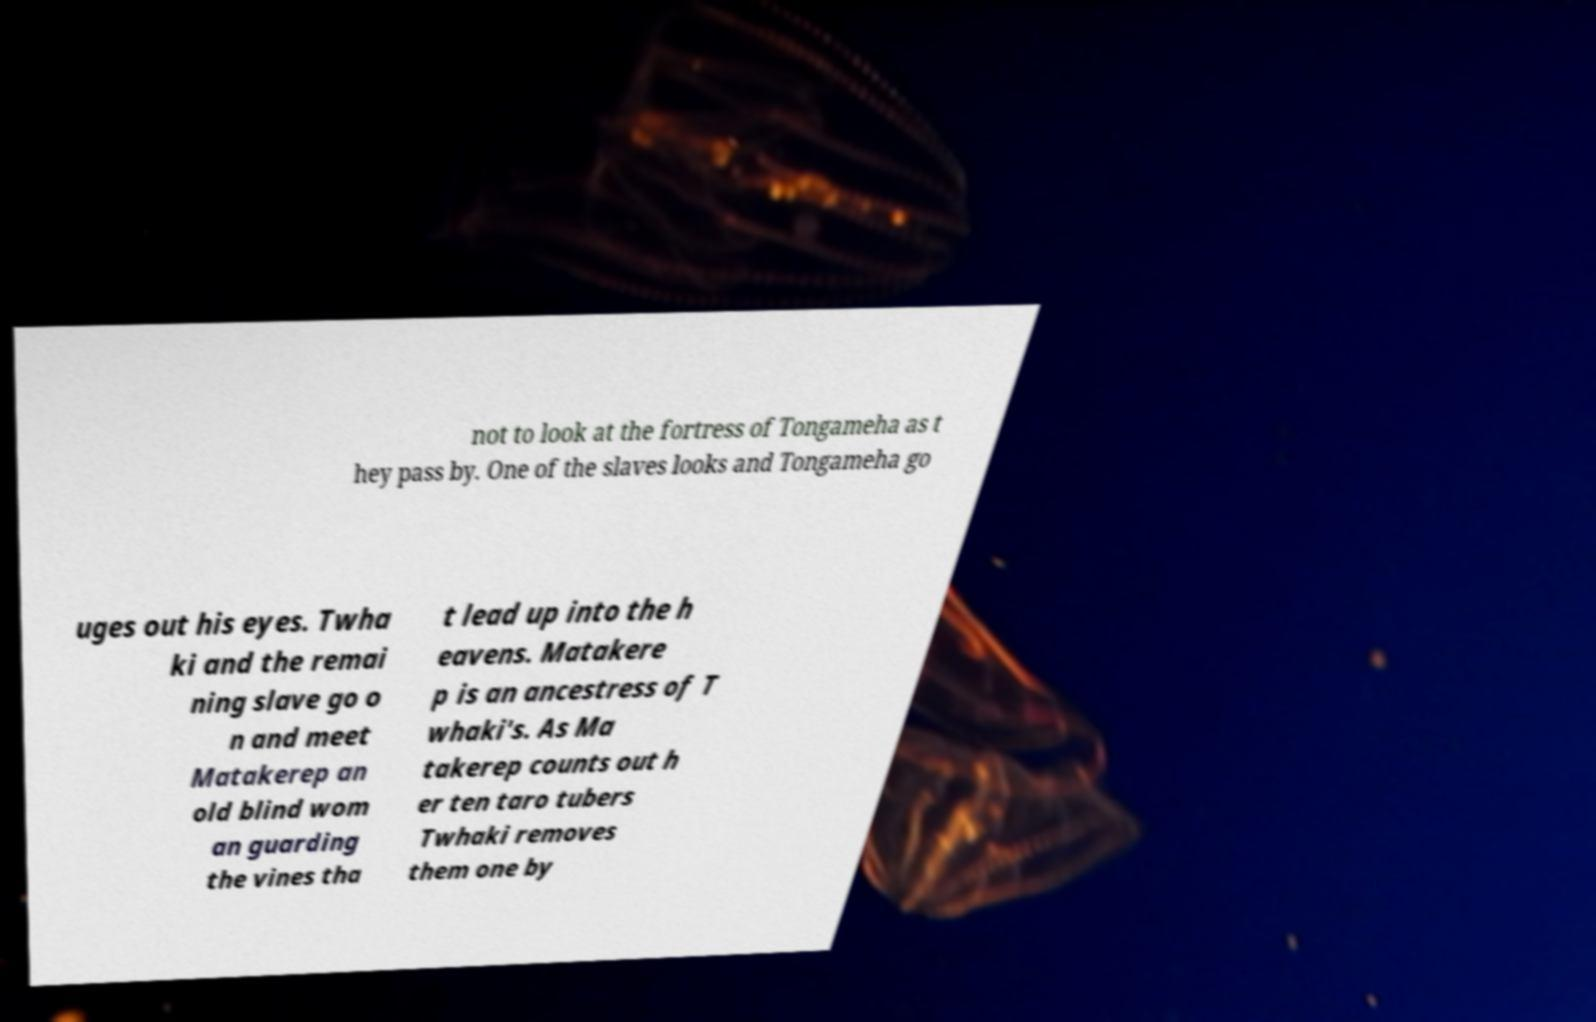Can you read and provide the text displayed in the image?This photo seems to have some interesting text. Can you extract and type it out for me? not to look at the fortress of Tongameha as t hey pass by. One of the slaves looks and Tongameha go uges out his eyes. Twha ki and the remai ning slave go o n and meet Matakerep an old blind wom an guarding the vines tha t lead up into the h eavens. Matakere p is an ancestress of T whaki's. As Ma takerep counts out h er ten taro tubers Twhaki removes them one by 